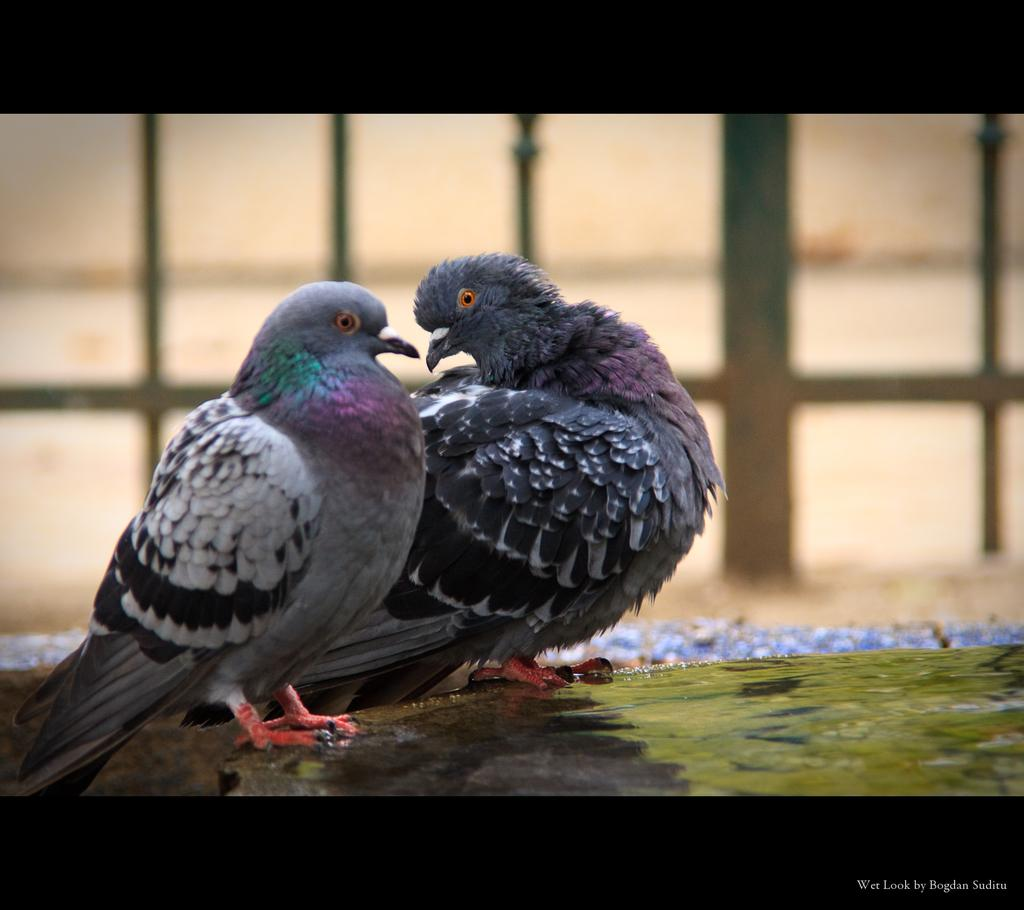What animals are present in the image? There are two doves in the image. What are the doves doing in the image? The doves are standing. Can you describe the background of the image? The background of the image is blurry. What architectural feature can be seen in the background? There are grilles visible in the background of the image. Where is the text located in the image? The text is at the right bottom of the image. What type of dust can be seen on the doves in the image? There is no dust visible on the doves in the image. What kind of popcorn is being served in the image? There is no popcorn present in the image. 